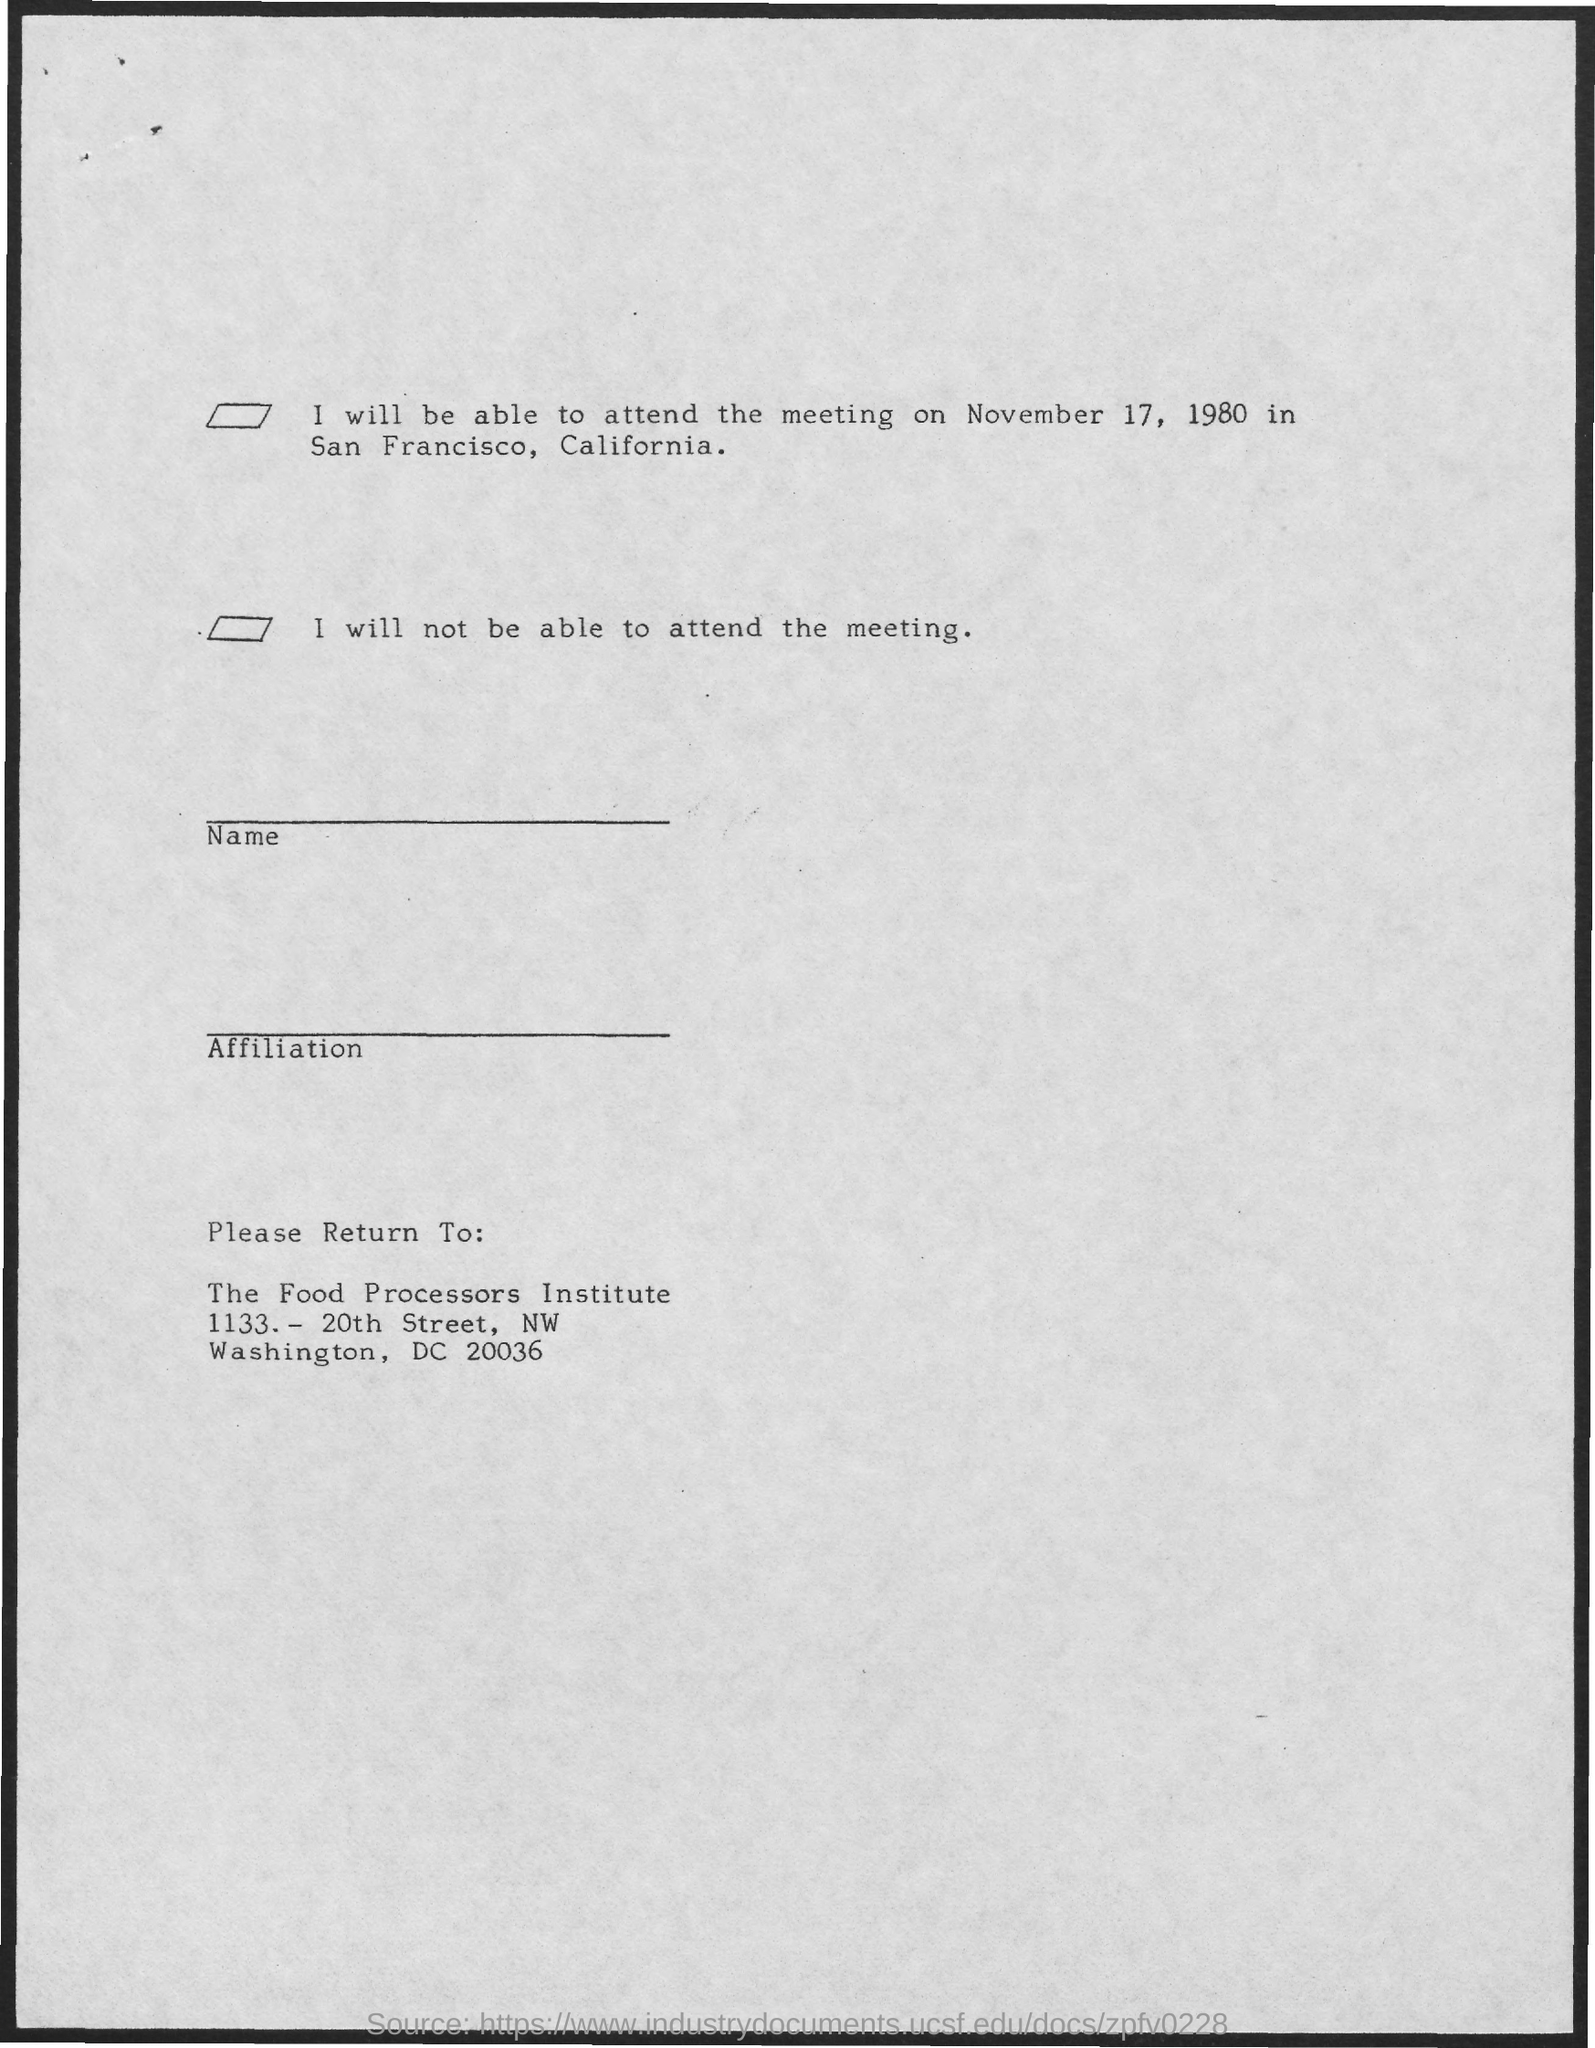What is the name of the institute?
Provide a short and direct response. The food processors institute. Where is San Francisco ?
Offer a terse response. California. Find the meeting date from the page?
Provide a short and direct response. November 17, 1980. 